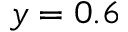<formula> <loc_0><loc_0><loc_500><loc_500>y = 0 . 6</formula> 